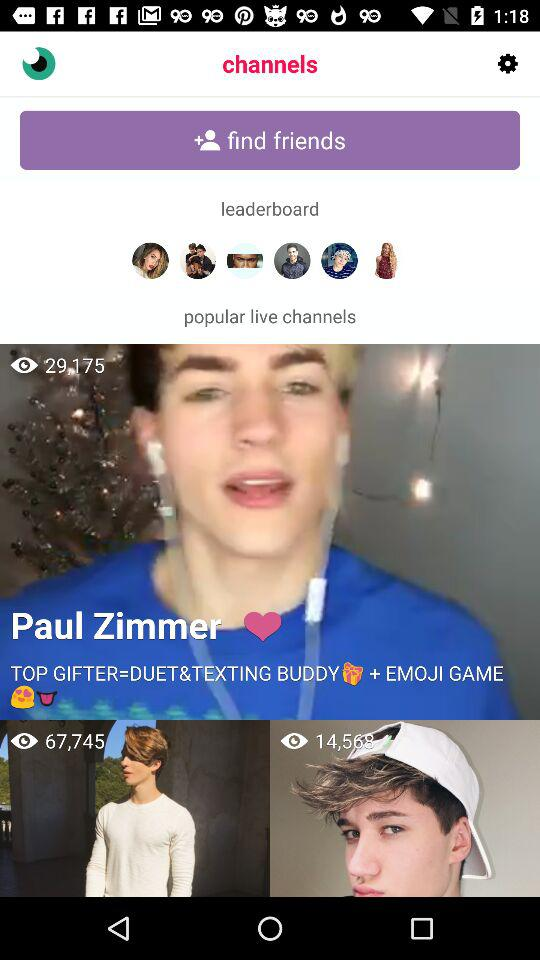How many viewers are watching the live stream by Paul Zimmer? There are 29,175 viewers who are watching the live stream by Paul Zimmer. 